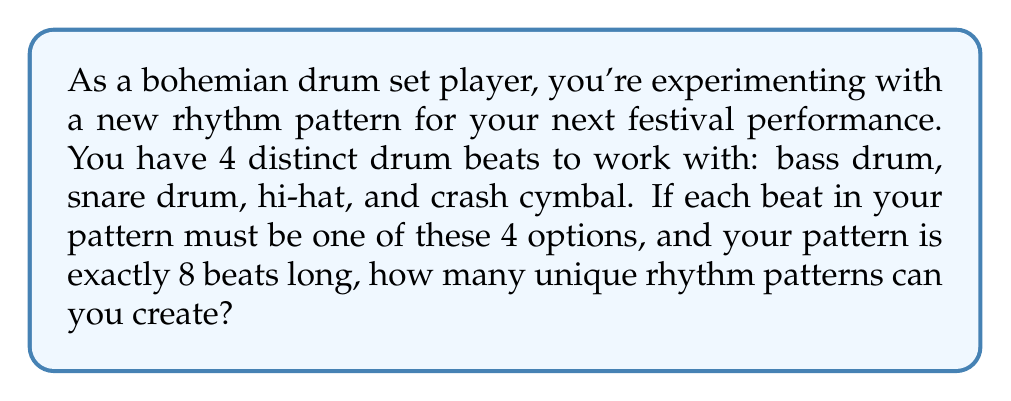Teach me how to tackle this problem. To solve this problem, we need to use the fundamental counting principle. Here's how we can break it down:

1) For each of the 8 beats in the pattern, we have 4 choices (bass drum, snare drum, hi-hat, or crash cymbal).

2) These choices are independent of each other, meaning our choice for one beat doesn't affect our choices for the other beats.

3) According to the fundamental counting principle, if we have a series of independent choices, we multiply the number of options for each choice to get the total number of possible outcomes.

4) In this case, we have 4 choices for each of the 8 beats. Mathematically, this can be expressed as:

   $$4^8$$

5) To calculate this:
   $$4^8 = 4 \times 4 \times 4 \times 4 \times 4 \times 4 \times 4 \times 4 = 65,536$$

Therefore, you can create 65,536 unique rhythm patterns with these constraints.

This large number demonstrates the vast creative possibilities available to you as a drummer, even with a limited set of drum beats and a fixed pattern length.
Answer: $65,536$ unique rhythm patterns 